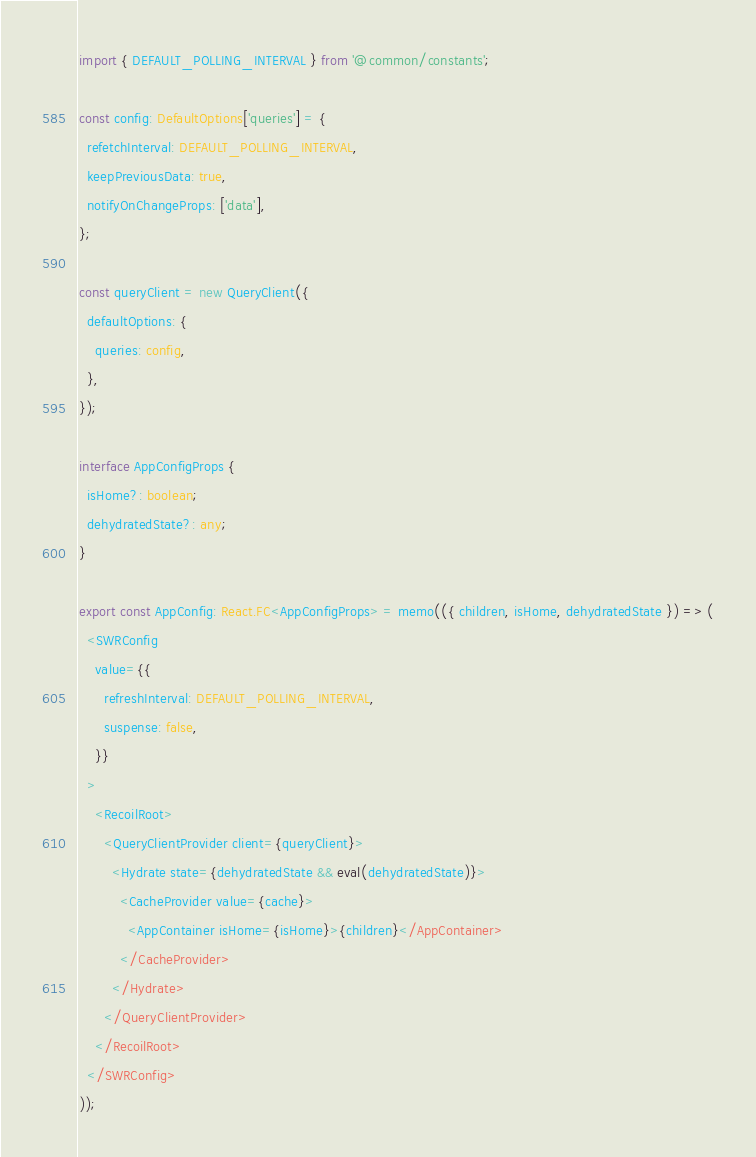Convert code to text. <code><loc_0><loc_0><loc_500><loc_500><_TypeScript_>import { DEFAULT_POLLING_INTERVAL } from '@common/constants';

const config: DefaultOptions['queries'] = {
  refetchInterval: DEFAULT_POLLING_INTERVAL,
  keepPreviousData: true,
  notifyOnChangeProps: ['data'],
};

const queryClient = new QueryClient({
  defaultOptions: {
    queries: config,
  },
});

interface AppConfigProps {
  isHome?: boolean;
  dehydratedState?: any;
}

export const AppConfig: React.FC<AppConfigProps> = memo(({ children, isHome, dehydratedState }) => (
  <SWRConfig
    value={{
      refreshInterval: DEFAULT_POLLING_INTERVAL,
      suspense: false,
    }}
  >
    <RecoilRoot>
      <QueryClientProvider client={queryClient}>
        <Hydrate state={dehydratedState && eval(dehydratedState)}>
          <CacheProvider value={cache}>
            <AppContainer isHome={isHome}>{children}</AppContainer>
          </CacheProvider>
        </Hydrate>
      </QueryClientProvider>
    </RecoilRoot>
  </SWRConfig>
));
</code> 